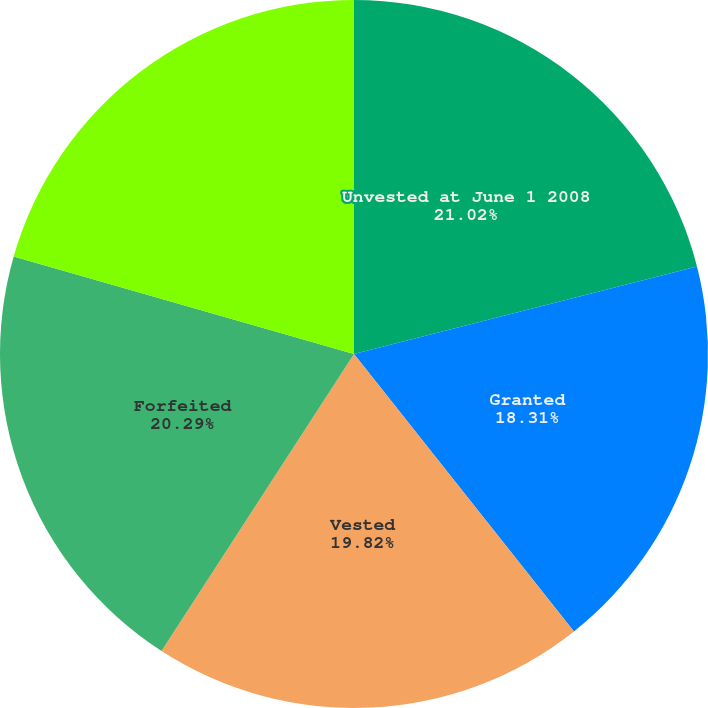Convert chart. <chart><loc_0><loc_0><loc_500><loc_500><pie_chart><fcel>Unvested at June 1 2008<fcel>Granted<fcel>Vested<fcel>Forfeited<fcel>Unvested at May 31 2009<nl><fcel>21.02%<fcel>18.31%<fcel>19.82%<fcel>20.29%<fcel>20.56%<nl></chart> 